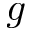<formula> <loc_0><loc_0><loc_500><loc_500>g</formula> 